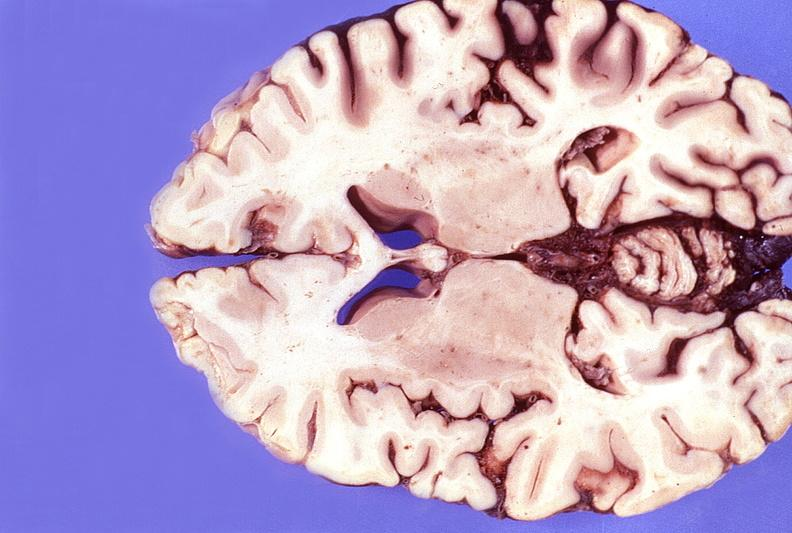what does this image show?
Answer the question using a single word or phrase. Normal brain 